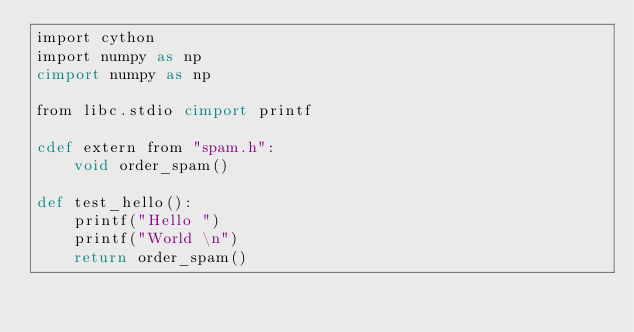Convert code to text. <code><loc_0><loc_0><loc_500><loc_500><_Cython_>import cython
import numpy as np
cimport numpy as np

from libc.stdio cimport printf

cdef extern from "spam.h":
    void order_spam()

def test_hello():
    printf("Hello ")
    printf("World \n")
    return order_spam()
</code> 